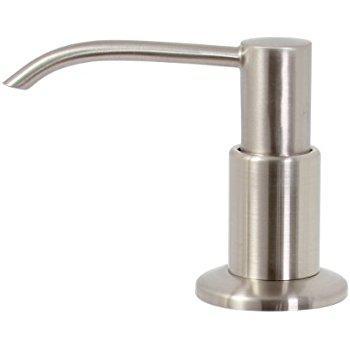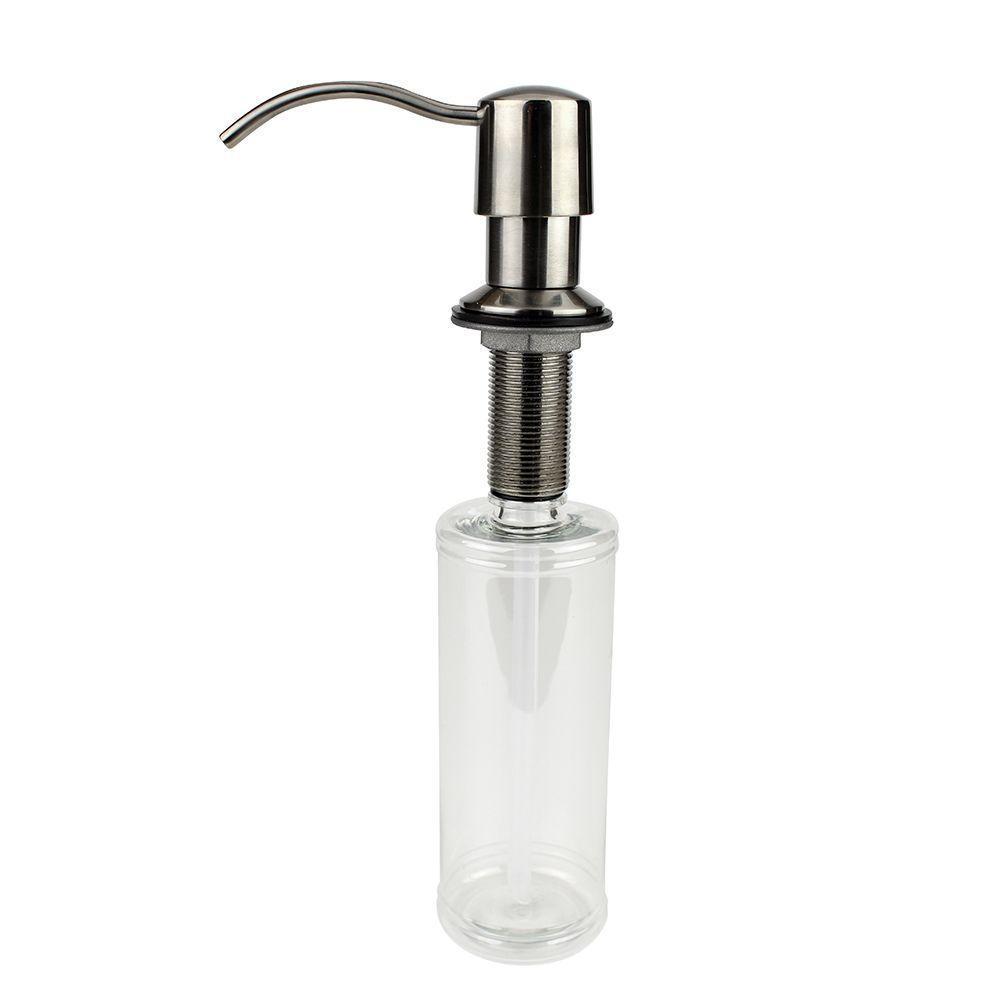The first image is the image on the left, the second image is the image on the right. Evaluate the accuracy of this statement regarding the images: "The pump on the left is not connected to a container.". Is it true? Answer yes or no. Yes. 